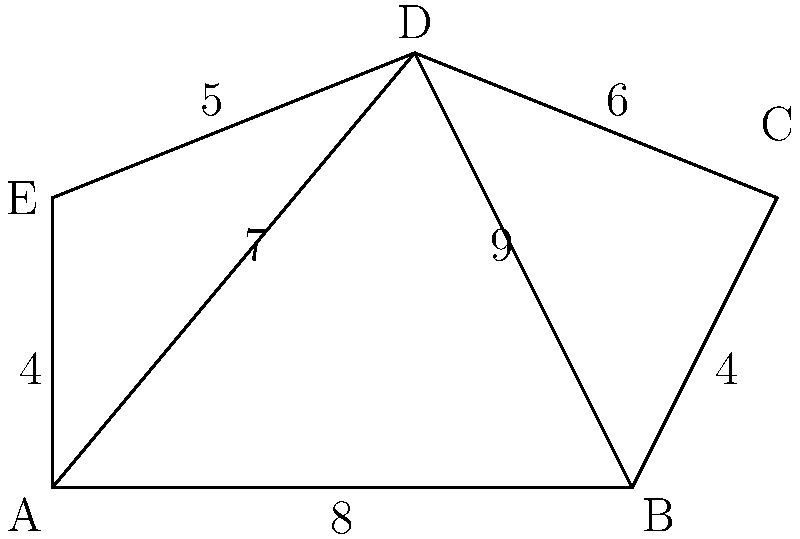You're planning a groovy retro concert, and the stage is shaped like an irregular pentagon ABCDE as shown. The stage can be divided into three triangles: ABD, BCD, and ADE. Given the side lengths in meters, calculate the total area of the stage to ensure you have enough space for your vintage turntables and speakers. Let's break this down step-by-step using Heron's formula for each triangle:

1) Heron's formula: $A = \sqrt{s(s-a)(s-b)(s-c)}$, where $s = \frac{a+b+c}{2}$ (semi-perimeter)

2) For triangle ABD:
   $a = 8$, $b = 9$, $c = 7$
   $s = \frac{8+9+7}{2} = 12$
   $A_{ABD} = \sqrt{12(12-8)(12-9)(12-7)} = \sqrt{12 \cdot 4 \cdot 3 \cdot 5} = \sqrt{720} = 6\sqrt{5}$

3) For triangle BCD:
   $a = 4$, $b = 6$, $c = 9$
   $s = \frac{4+6+9}{2} = 9.5$
   $A_{BCD} = \sqrt{9.5(9.5-4)(9.5-6)(9.5-9)} = \sqrt{9.5 \cdot 5.5 \cdot 3.5 \cdot 0.5} = \sqrt{91.4375} \approx 9.56$

4) For triangle ADE:
   $a = 4$, $b = 5$, $c = 7$
   $s = \frac{4+5+7}{2} = 8$
   $A_{ADE} = \sqrt{8(8-4)(8-5)(8-7)} = \sqrt{8 \cdot 4 \cdot 3 \cdot 1} = \sqrt{96} = 4\sqrt{6}$

5) Total area:
   $A_{total} = A_{ABD} + A_{BCD} + A_{ADE}$
   $A_{total} = 6\sqrt{5} + 9.56 + 4\sqrt{6}$
   $A_{total} \approx 13.42 + 9.56 + 9.80 = 32.78$ square meters
Answer: $32.78 \text{ m}^2$ 